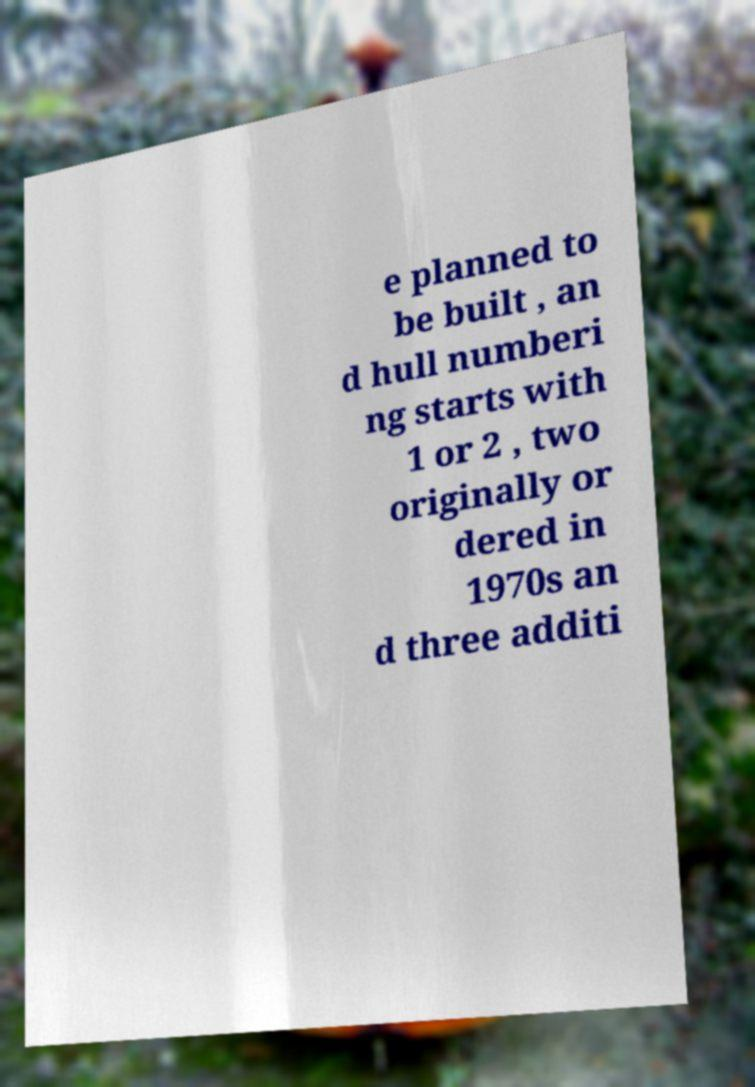What messages or text are displayed in this image? I need them in a readable, typed format. e planned to be built , an d hull numberi ng starts with 1 or 2 , two originally or dered in 1970s an d three additi 